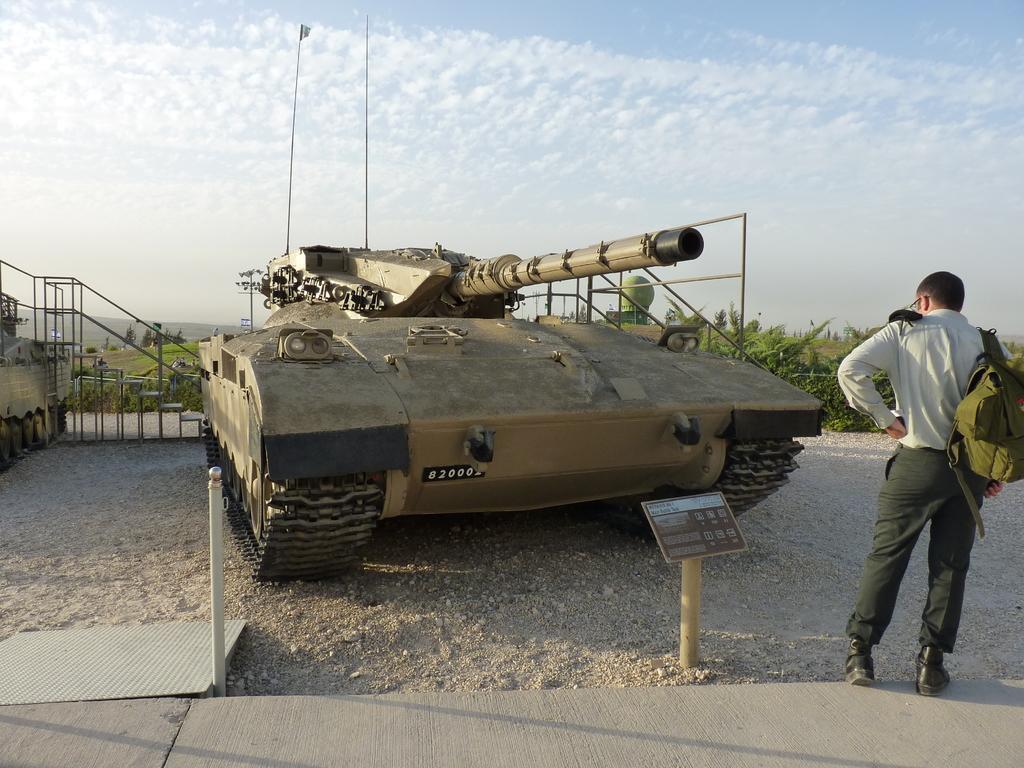Please provide a concise description of this image. There is a person standing and wore bag and we can see tank. Background we can see trees and sky. 